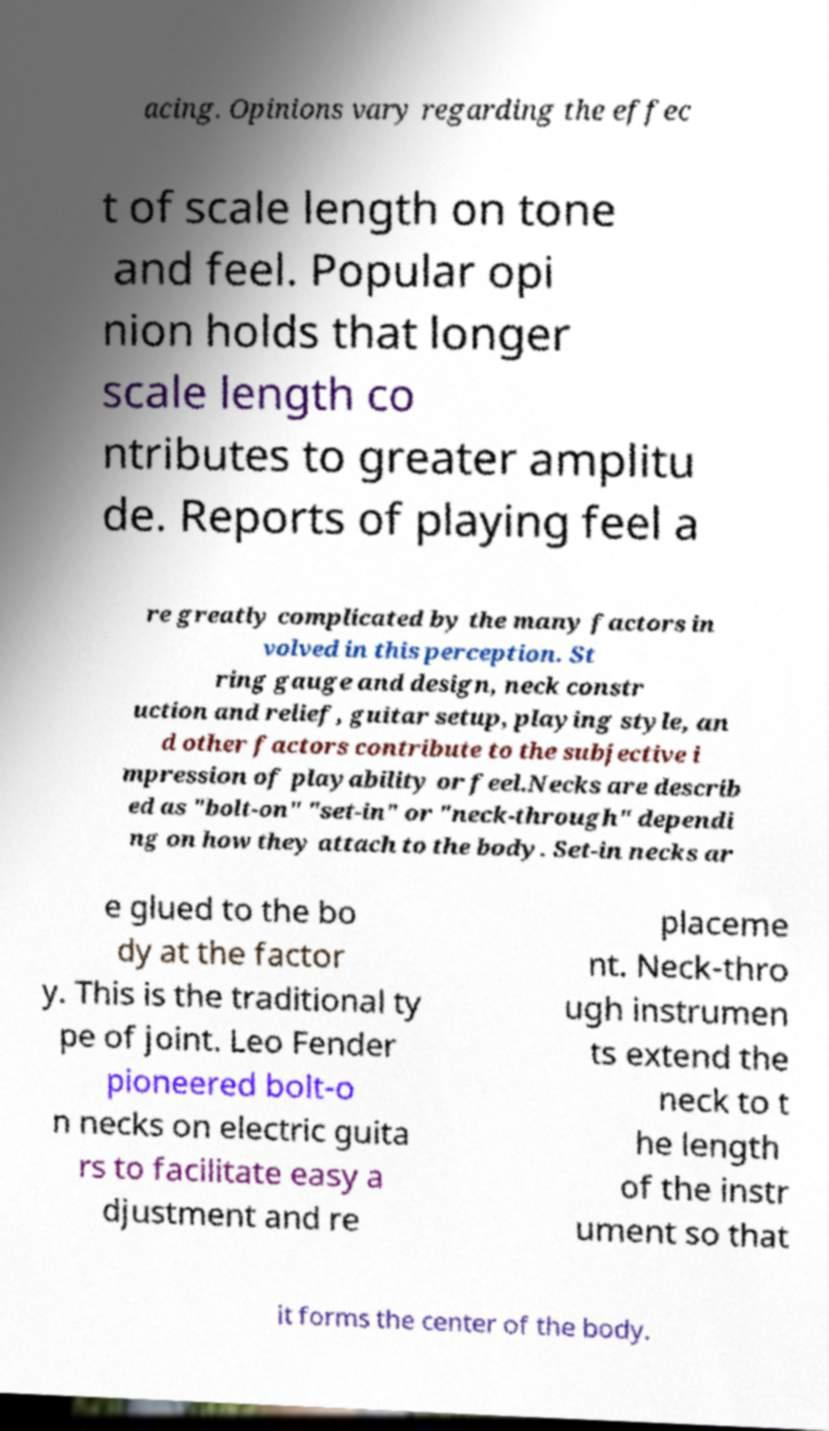I need the written content from this picture converted into text. Can you do that? acing. Opinions vary regarding the effec t of scale length on tone and feel. Popular opi nion holds that longer scale length co ntributes to greater amplitu de. Reports of playing feel a re greatly complicated by the many factors in volved in this perception. St ring gauge and design, neck constr uction and relief, guitar setup, playing style, an d other factors contribute to the subjective i mpression of playability or feel.Necks are describ ed as "bolt-on" "set-in" or "neck-through" dependi ng on how they attach to the body. Set-in necks ar e glued to the bo dy at the factor y. This is the traditional ty pe of joint. Leo Fender pioneered bolt-o n necks on electric guita rs to facilitate easy a djustment and re placeme nt. Neck-thro ugh instrumen ts extend the neck to t he length of the instr ument so that it forms the center of the body. 